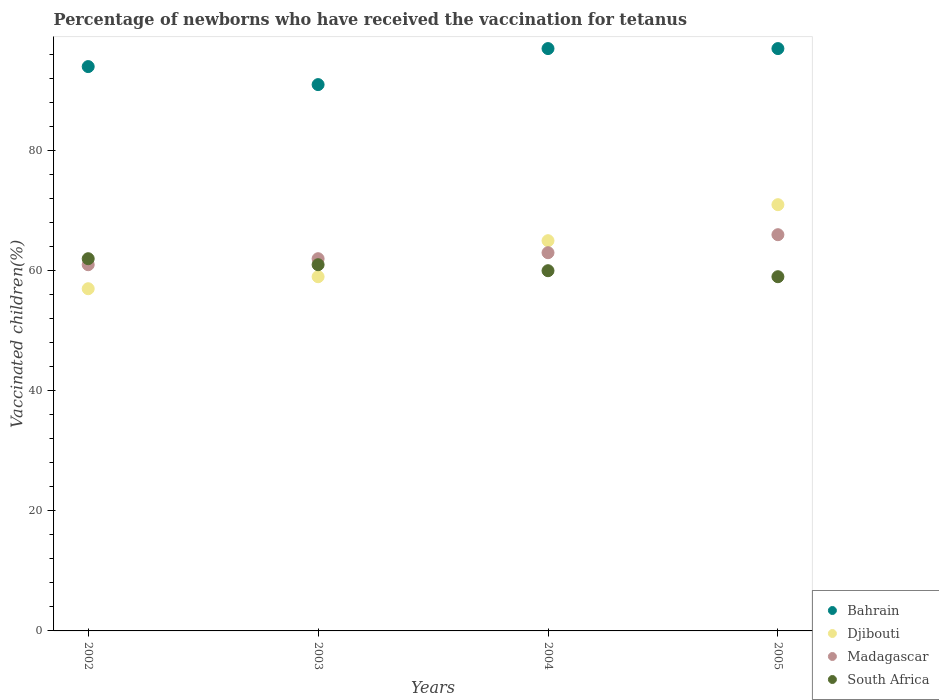How many different coloured dotlines are there?
Ensure brevity in your answer.  4. Is the number of dotlines equal to the number of legend labels?
Your answer should be very brief. Yes. What is the percentage of vaccinated children in Bahrain in 2002?
Your answer should be very brief. 94. Across all years, what is the maximum percentage of vaccinated children in Bahrain?
Ensure brevity in your answer.  97. Across all years, what is the minimum percentage of vaccinated children in South Africa?
Keep it short and to the point. 59. What is the total percentage of vaccinated children in South Africa in the graph?
Your answer should be very brief. 242. What is the difference between the percentage of vaccinated children in South Africa in 2003 and that in 2004?
Keep it short and to the point. 1. In the year 2004, what is the difference between the percentage of vaccinated children in South Africa and percentage of vaccinated children in Djibouti?
Offer a terse response. -5. What is the ratio of the percentage of vaccinated children in Bahrain in 2004 to that in 2005?
Your answer should be compact. 1. Is the percentage of vaccinated children in South Africa in 2004 less than that in 2005?
Provide a short and direct response. No. Is the difference between the percentage of vaccinated children in South Africa in 2003 and 2004 greater than the difference between the percentage of vaccinated children in Djibouti in 2003 and 2004?
Ensure brevity in your answer.  Yes. What is the difference between the highest and the lowest percentage of vaccinated children in Madagascar?
Ensure brevity in your answer.  5. In how many years, is the percentage of vaccinated children in Bahrain greater than the average percentage of vaccinated children in Bahrain taken over all years?
Your answer should be compact. 2. Is the sum of the percentage of vaccinated children in Djibouti in 2003 and 2004 greater than the maximum percentage of vaccinated children in Bahrain across all years?
Ensure brevity in your answer.  Yes. Is it the case that in every year, the sum of the percentage of vaccinated children in Madagascar and percentage of vaccinated children in Djibouti  is greater than the percentage of vaccinated children in South Africa?
Ensure brevity in your answer.  Yes. Does the percentage of vaccinated children in Bahrain monotonically increase over the years?
Keep it short and to the point. No. Is the percentage of vaccinated children in South Africa strictly greater than the percentage of vaccinated children in Madagascar over the years?
Make the answer very short. No. Is the percentage of vaccinated children in Bahrain strictly less than the percentage of vaccinated children in South Africa over the years?
Provide a short and direct response. No. How many dotlines are there?
Provide a succinct answer. 4. How many years are there in the graph?
Keep it short and to the point. 4. Are the values on the major ticks of Y-axis written in scientific E-notation?
Ensure brevity in your answer.  No. Does the graph contain any zero values?
Your response must be concise. No. Does the graph contain grids?
Offer a very short reply. No. How many legend labels are there?
Provide a succinct answer. 4. How are the legend labels stacked?
Make the answer very short. Vertical. What is the title of the graph?
Offer a very short reply. Percentage of newborns who have received the vaccination for tetanus. Does "Netherlands" appear as one of the legend labels in the graph?
Your answer should be compact. No. What is the label or title of the X-axis?
Provide a succinct answer. Years. What is the label or title of the Y-axis?
Your answer should be compact. Vaccinated children(%). What is the Vaccinated children(%) in Bahrain in 2002?
Give a very brief answer. 94. What is the Vaccinated children(%) of South Africa in 2002?
Your answer should be very brief. 62. What is the Vaccinated children(%) of Bahrain in 2003?
Make the answer very short. 91. What is the Vaccinated children(%) of Madagascar in 2003?
Keep it short and to the point. 62. What is the Vaccinated children(%) of South Africa in 2003?
Your answer should be very brief. 61. What is the Vaccinated children(%) of Bahrain in 2004?
Provide a short and direct response. 97. What is the Vaccinated children(%) of Madagascar in 2004?
Ensure brevity in your answer.  63. What is the Vaccinated children(%) of South Africa in 2004?
Offer a terse response. 60. What is the Vaccinated children(%) of Bahrain in 2005?
Keep it short and to the point. 97. What is the Vaccinated children(%) in South Africa in 2005?
Your answer should be very brief. 59. Across all years, what is the maximum Vaccinated children(%) in Bahrain?
Give a very brief answer. 97. Across all years, what is the maximum Vaccinated children(%) of Djibouti?
Your answer should be compact. 71. Across all years, what is the maximum Vaccinated children(%) of Madagascar?
Offer a terse response. 66. Across all years, what is the maximum Vaccinated children(%) of South Africa?
Provide a short and direct response. 62. Across all years, what is the minimum Vaccinated children(%) in Bahrain?
Provide a succinct answer. 91. Across all years, what is the minimum Vaccinated children(%) in Madagascar?
Provide a short and direct response. 61. What is the total Vaccinated children(%) of Bahrain in the graph?
Give a very brief answer. 379. What is the total Vaccinated children(%) of Djibouti in the graph?
Ensure brevity in your answer.  252. What is the total Vaccinated children(%) in Madagascar in the graph?
Your answer should be very brief. 252. What is the total Vaccinated children(%) of South Africa in the graph?
Give a very brief answer. 242. What is the difference between the Vaccinated children(%) in Madagascar in 2002 and that in 2003?
Ensure brevity in your answer.  -1. What is the difference between the Vaccinated children(%) in Bahrain in 2002 and that in 2004?
Keep it short and to the point. -3. What is the difference between the Vaccinated children(%) in Djibouti in 2002 and that in 2004?
Give a very brief answer. -8. What is the difference between the Vaccinated children(%) in Madagascar in 2002 and that in 2004?
Your response must be concise. -2. What is the difference between the Vaccinated children(%) in South Africa in 2002 and that in 2004?
Keep it short and to the point. 2. What is the difference between the Vaccinated children(%) in Bahrain in 2002 and that in 2005?
Offer a very short reply. -3. What is the difference between the Vaccinated children(%) in Djibouti in 2003 and that in 2004?
Offer a terse response. -6. What is the difference between the Vaccinated children(%) in Madagascar in 2003 and that in 2004?
Provide a succinct answer. -1. What is the difference between the Vaccinated children(%) in Djibouti in 2004 and that in 2005?
Your answer should be very brief. -6. What is the difference between the Vaccinated children(%) in Bahrain in 2002 and the Vaccinated children(%) in Djibouti in 2003?
Your response must be concise. 35. What is the difference between the Vaccinated children(%) of Bahrain in 2002 and the Vaccinated children(%) of Madagascar in 2003?
Make the answer very short. 32. What is the difference between the Vaccinated children(%) in Bahrain in 2002 and the Vaccinated children(%) in South Africa in 2003?
Your answer should be very brief. 33. What is the difference between the Vaccinated children(%) in Madagascar in 2002 and the Vaccinated children(%) in South Africa in 2003?
Offer a terse response. 0. What is the difference between the Vaccinated children(%) in Bahrain in 2002 and the Vaccinated children(%) in Djibouti in 2004?
Give a very brief answer. 29. What is the difference between the Vaccinated children(%) in Madagascar in 2002 and the Vaccinated children(%) in South Africa in 2004?
Keep it short and to the point. 1. What is the difference between the Vaccinated children(%) in Bahrain in 2002 and the Vaccinated children(%) in Djibouti in 2005?
Give a very brief answer. 23. What is the difference between the Vaccinated children(%) of Bahrain in 2002 and the Vaccinated children(%) of Madagascar in 2005?
Your response must be concise. 28. What is the difference between the Vaccinated children(%) in Bahrain in 2002 and the Vaccinated children(%) in South Africa in 2005?
Give a very brief answer. 35. What is the difference between the Vaccinated children(%) of Djibouti in 2002 and the Vaccinated children(%) of Madagascar in 2005?
Your answer should be compact. -9. What is the difference between the Vaccinated children(%) of Djibouti in 2002 and the Vaccinated children(%) of South Africa in 2005?
Offer a terse response. -2. What is the difference between the Vaccinated children(%) in Madagascar in 2002 and the Vaccinated children(%) in South Africa in 2005?
Keep it short and to the point. 2. What is the difference between the Vaccinated children(%) in Djibouti in 2003 and the Vaccinated children(%) in Madagascar in 2004?
Your answer should be very brief. -4. What is the difference between the Vaccinated children(%) of Madagascar in 2003 and the Vaccinated children(%) of South Africa in 2004?
Make the answer very short. 2. What is the difference between the Vaccinated children(%) of Bahrain in 2003 and the Vaccinated children(%) of Djibouti in 2005?
Give a very brief answer. 20. What is the difference between the Vaccinated children(%) in Bahrain in 2003 and the Vaccinated children(%) in Madagascar in 2005?
Offer a very short reply. 25. What is the difference between the Vaccinated children(%) in Bahrain in 2003 and the Vaccinated children(%) in South Africa in 2005?
Your response must be concise. 32. What is the difference between the Vaccinated children(%) of Djibouti in 2004 and the Vaccinated children(%) of South Africa in 2005?
Your answer should be very brief. 6. What is the average Vaccinated children(%) in Bahrain per year?
Your answer should be very brief. 94.75. What is the average Vaccinated children(%) in Madagascar per year?
Your response must be concise. 63. What is the average Vaccinated children(%) in South Africa per year?
Provide a succinct answer. 60.5. In the year 2002, what is the difference between the Vaccinated children(%) of Bahrain and Vaccinated children(%) of Djibouti?
Give a very brief answer. 37. In the year 2002, what is the difference between the Vaccinated children(%) of Bahrain and Vaccinated children(%) of South Africa?
Provide a succinct answer. 32. In the year 2002, what is the difference between the Vaccinated children(%) in Djibouti and Vaccinated children(%) in Madagascar?
Keep it short and to the point. -4. In the year 2002, what is the difference between the Vaccinated children(%) of Madagascar and Vaccinated children(%) of South Africa?
Ensure brevity in your answer.  -1. In the year 2003, what is the difference between the Vaccinated children(%) of Bahrain and Vaccinated children(%) of South Africa?
Offer a terse response. 30. In the year 2003, what is the difference between the Vaccinated children(%) in Madagascar and Vaccinated children(%) in South Africa?
Your response must be concise. 1. In the year 2004, what is the difference between the Vaccinated children(%) of Bahrain and Vaccinated children(%) of Djibouti?
Your response must be concise. 32. In the year 2004, what is the difference between the Vaccinated children(%) of Bahrain and Vaccinated children(%) of Madagascar?
Offer a terse response. 34. In the year 2004, what is the difference between the Vaccinated children(%) in Djibouti and Vaccinated children(%) in South Africa?
Make the answer very short. 5. In the year 2004, what is the difference between the Vaccinated children(%) of Madagascar and Vaccinated children(%) of South Africa?
Your answer should be very brief. 3. In the year 2005, what is the difference between the Vaccinated children(%) of Bahrain and Vaccinated children(%) of South Africa?
Your answer should be very brief. 38. In the year 2005, what is the difference between the Vaccinated children(%) of Djibouti and Vaccinated children(%) of South Africa?
Offer a terse response. 12. What is the ratio of the Vaccinated children(%) of Bahrain in 2002 to that in 2003?
Offer a very short reply. 1.03. What is the ratio of the Vaccinated children(%) of Djibouti in 2002 to that in 2003?
Make the answer very short. 0.97. What is the ratio of the Vaccinated children(%) in Madagascar in 2002 to that in 2003?
Provide a short and direct response. 0.98. What is the ratio of the Vaccinated children(%) in South Africa in 2002 to that in 2003?
Provide a short and direct response. 1.02. What is the ratio of the Vaccinated children(%) of Bahrain in 2002 to that in 2004?
Your response must be concise. 0.97. What is the ratio of the Vaccinated children(%) in Djibouti in 2002 to that in 2004?
Provide a short and direct response. 0.88. What is the ratio of the Vaccinated children(%) in Madagascar in 2002 to that in 2004?
Offer a terse response. 0.97. What is the ratio of the Vaccinated children(%) in South Africa in 2002 to that in 2004?
Ensure brevity in your answer.  1.03. What is the ratio of the Vaccinated children(%) in Bahrain in 2002 to that in 2005?
Ensure brevity in your answer.  0.97. What is the ratio of the Vaccinated children(%) in Djibouti in 2002 to that in 2005?
Offer a terse response. 0.8. What is the ratio of the Vaccinated children(%) of Madagascar in 2002 to that in 2005?
Ensure brevity in your answer.  0.92. What is the ratio of the Vaccinated children(%) of South Africa in 2002 to that in 2005?
Ensure brevity in your answer.  1.05. What is the ratio of the Vaccinated children(%) in Bahrain in 2003 to that in 2004?
Provide a short and direct response. 0.94. What is the ratio of the Vaccinated children(%) of Djibouti in 2003 to that in 2004?
Provide a succinct answer. 0.91. What is the ratio of the Vaccinated children(%) of Madagascar in 2003 to that in 2004?
Your answer should be very brief. 0.98. What is the ratio of the Vaccinated children(%) of South Africa in 2003 to that in 2004?
Make the answer very short. 1.02. What is the ratio of the Vaccinated children(%) of Bahrain in 2003 to that in 2005?
Your response must be concise. 0.94. What is the ratio of the Vaccinated children(%) in Djibouti in 2003 to that in 2005?
Make the answer very short. 0.83. What is the ratio of the Vaccinated children(%) of Madagascar in 2003 to that in 2005?
Keep it short and to the point. 0.94. What is the ratio of the Vaccinated children(%) of South Africa in 2003 to that in 2005?
Your answer should be very brief. 1.03. What is the ratio of the Vaccinated children(%) in Djibouti in 2004 to that in 2005?
Ensure brevity in your answer.  0.92. What is the ratio of the Vaccinated children(%) in Madagascar in 2004 to that in 2005?
Give a very brief answer. 0.95. What is the ratio of the Vaccinated children(%) in South Africa in 2004 to that in 2005?
Your answer should be compact. 1.02. What is the difference between the highest and the second highest Vaccinated children(%) of Bahrain?
Your answer should be compact. 0. What is the difference between the highest and the second highest Vaccinated children(%) in Djibouti?
Your answer should be compact. 6. What is the difference between the highest and the second highest Vaccinated children(%) of Madagascar?
Keep it short and to the point. 3. What is the difference between the highest and the second highest Vaccinated children(%) of South Africa?
Your answer should be very brief. 1. What is the difference between the highest and the lowest Vaccinated children(%) in Bahrain?
Your response must be concise. 6. What is the difference between the highest and the lowest Vaccinated children(%) of Djibouti?
Give a very brief answer. 14. What is the difference between the highest and the lowest Vaccinated children(%) of Madagascar?
Give a very brief answer. 5. What is the difference between the highest and the lowest Vaccinated children(%) of South Africa?
Your answer should be compact. 3. 